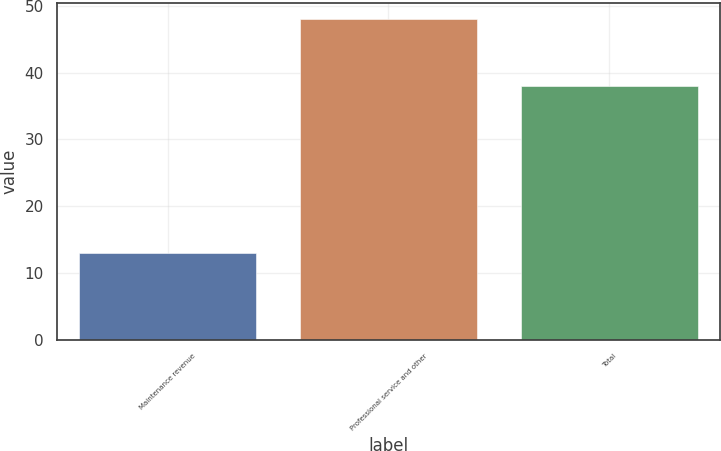Convert chart to OTSL. <chart><loc_0><loc_0><loc_500><loc_500><bar_chart><fcel>Maintenance revenue<fcel>Professional service and other<fcel>Total<nl><fcel>13<fcel>48<fcel>38<nl></chart> 